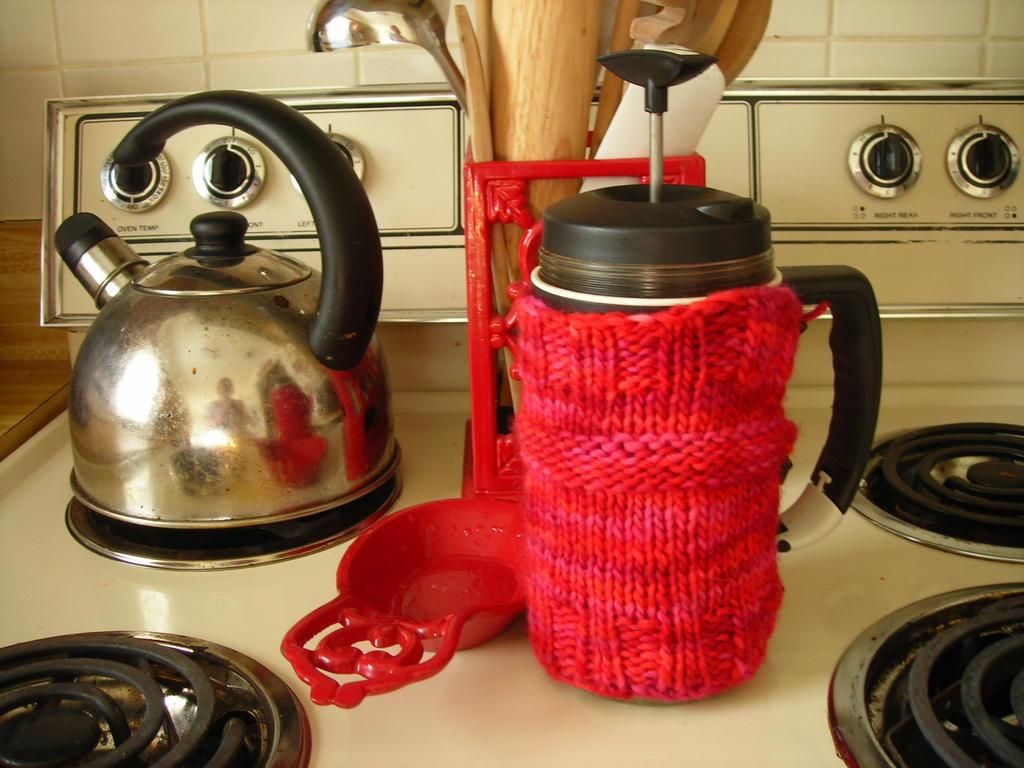Provide a one-sentence caption for the provided image. a stove top with oven dials with the words 'oven temp' underneath it. 